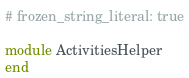Convert code to text. <code><loc_0><loc_0><loc_500><loc_500><_Ruby_># frozen_string_literal: true

module ActivitiesHelper
end
</code> 